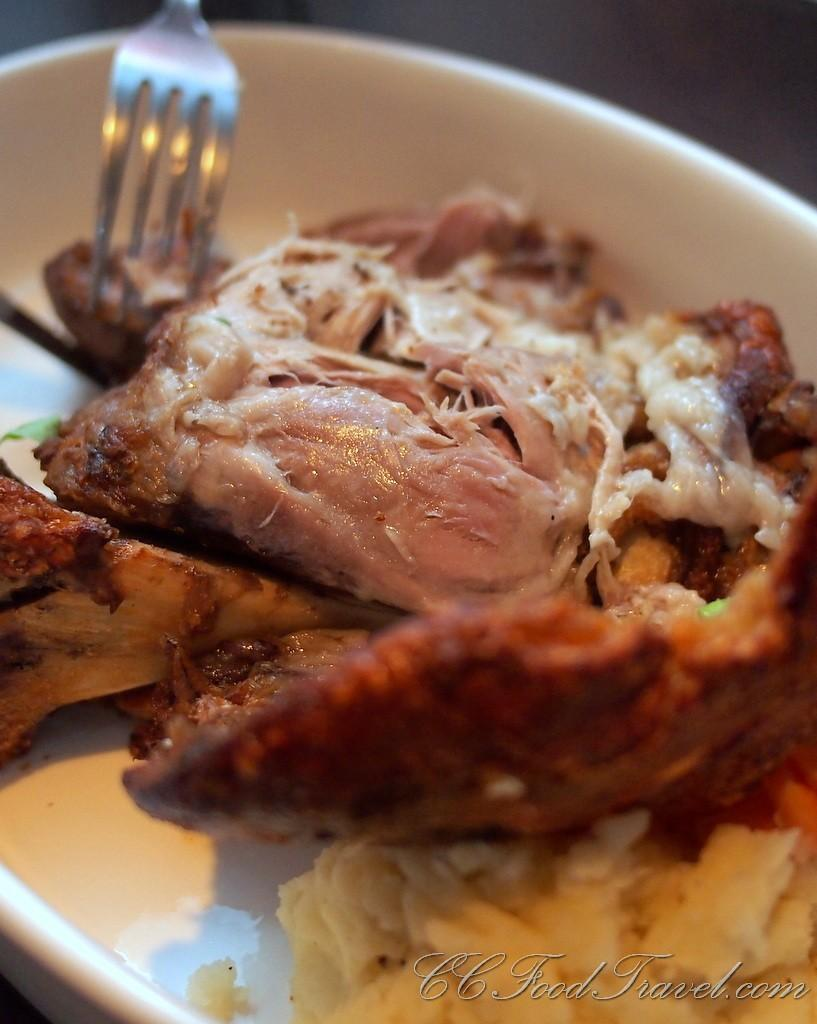What is the main subject of the image? The main subject of the image is food. How is the food arranged in the image? The food is in the center of a plate. What utensil is present in the image? There is a fork in the image. What type of cemetery can be seen in the background of the image? There is no cemetery present in the image; it features food in the center of a plate with a fork. 